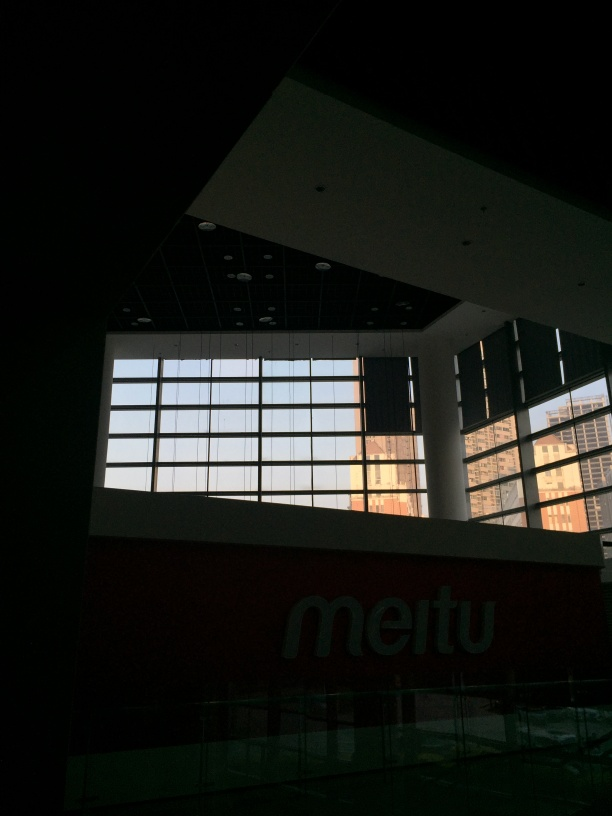What can this image tell us about the building's architecture and design? The image shows modern architectural elements such as a large glass window facade, which allows an abundance of natural light. The overall design seems minimalist, with clean lines and a lack of ornate detailing. The bold, contrasting colors, and the structural beam cutting diagonally through the composition add to the contemporary feel of the building. 